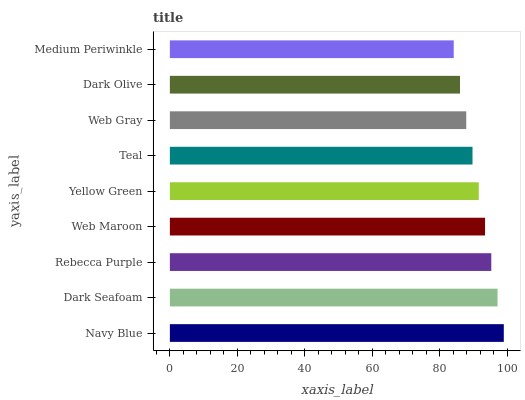Is Medium Periwinkle the minimum?
Answer yes or no. Yes. Is Navy Blue the maximum?
Answer yes or no. Yes. Is Dark Seafoam the minimum?
Answer yes or no. No. Is Dark Seafoam the maximum?
Answer yes or no. No. Is Navy Blue greater than Dark Seafoam?
Answer yes or no. Yes. Is Dark Seafoam less than Navy Blue?
Answer yes or no. Yes. Is Dark Seafoam greater than Navy Blue?
Answer yes or no. No. Is Navy Blue less than Dark Seafoam?
Answer yes or no. No. Is Yellow Green the high median?
Answer yes or no. Yes. Is Yellow Green the low median?
Answer yes or no. Yes. Is Web Gray the high median?
Answer yes or no. No. Is Dark Olive the low median?
Answer yes or no. No. 